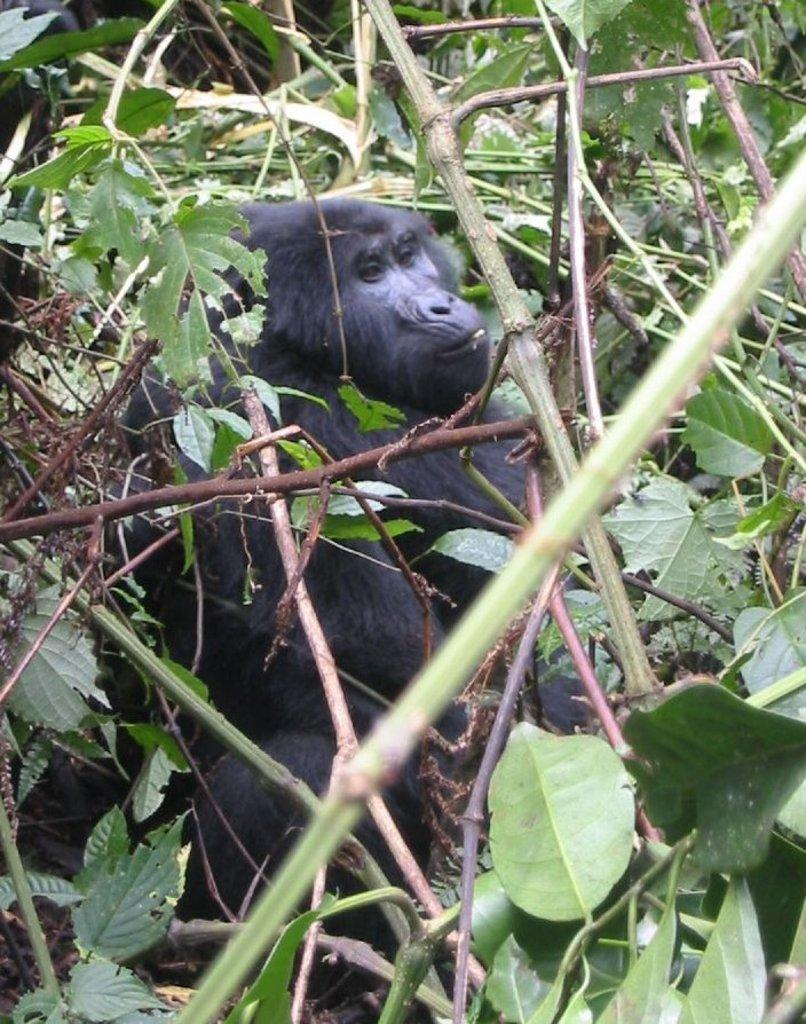What type of animal is in the image? There is a gorilla in the image. What can be seen in the background of the image? There are trees with leaves and branches in the image. What type of ship can be seen sailing in the background of the image? There is no ship present in the image; it only features a gorilla and trees with leaves and branches. 